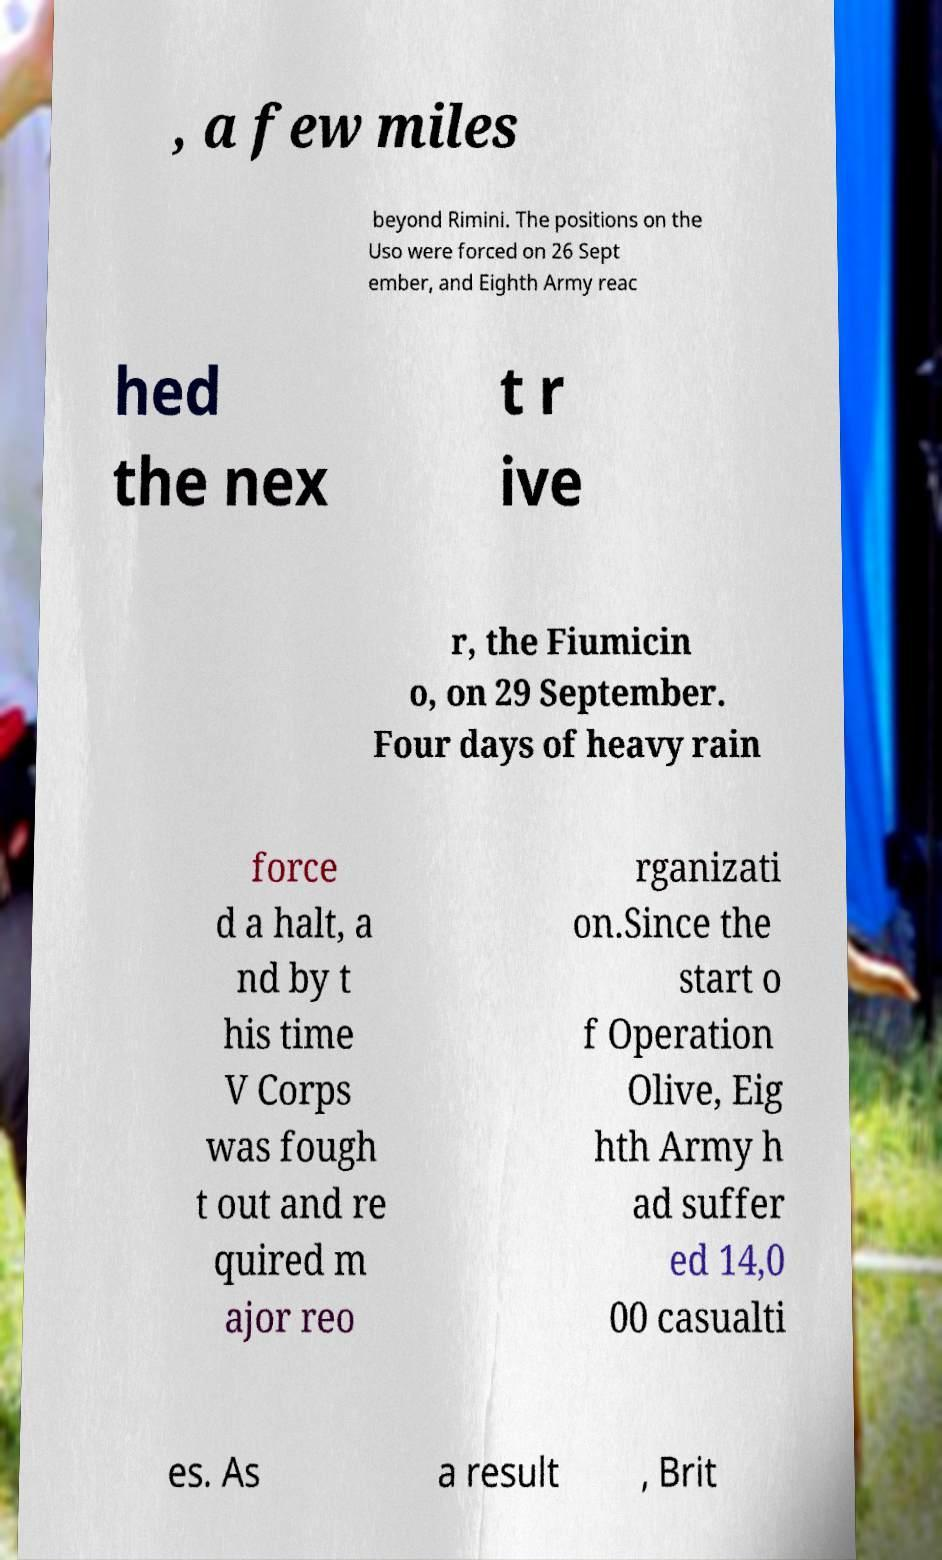There's text embedded in this image that I need extracted. Can you transcribe it verbatim? , a few miles beyond Rimini. The positions on the Uso were forced on 26 Sept ember, and Eighth Army reac hed the nex t r ive r, the Fiumicin o, on 29 September. Four days of heavy rain force d a halt, a nd by t his time V Corps was fough t out and re quired m ajor reo rganizati on.Since the start o f Operation Olive, Eig hth Army h ad suffer ed 14,0 00 casualti es. As a result , Brit 